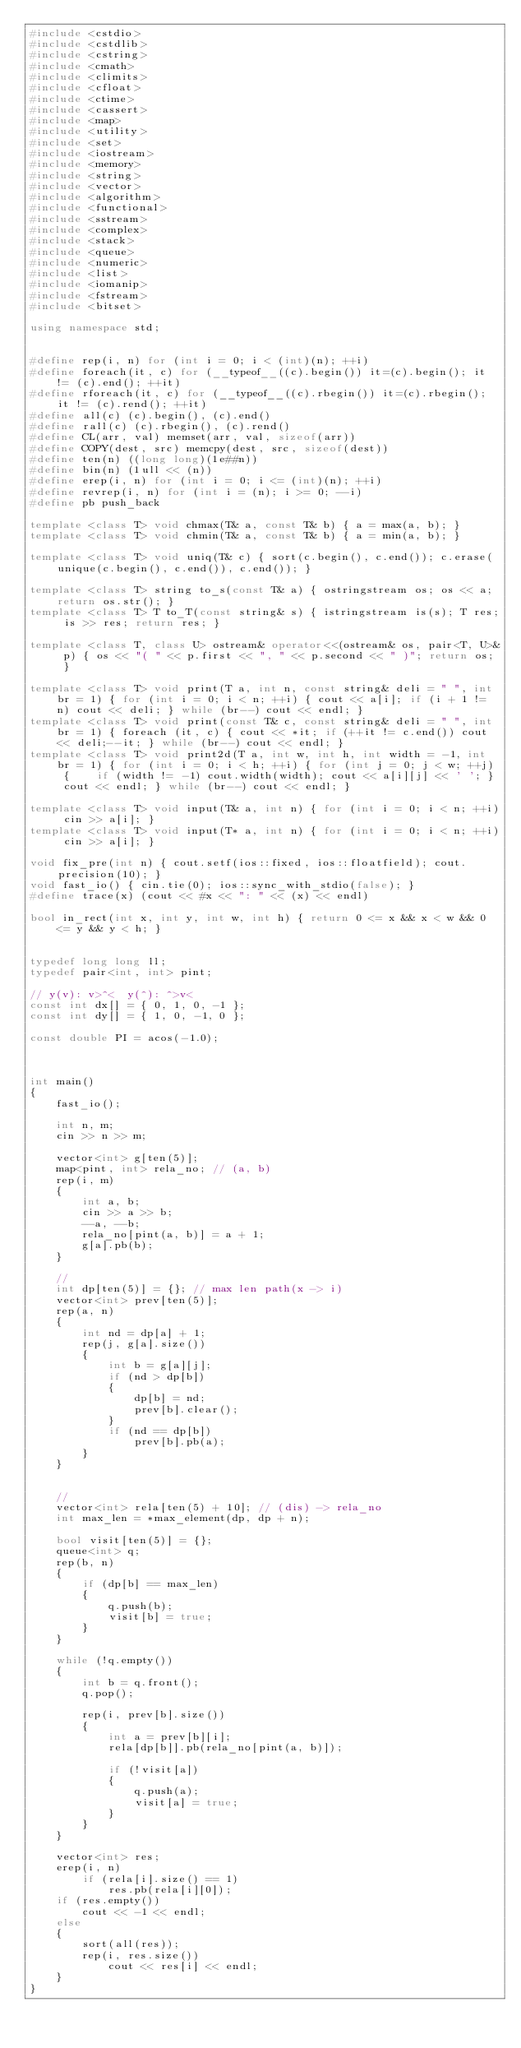Convert code to text. <code><loc_0><loc_0><loc_500><loc_500><_C++_>#include <cstdio>
#include <cstdlib>
#include <cstring>
#include <cmath>
#include <climits>
#include <cfloat>
#include <ctime>
#include <cassert>
#include <map>
#include <utility>
#include <set>
#include <iostream>
#include <memory>
#include <string>
#include <vector>
#include <algorithm>
#include <functional>
#include <sstream>
#include <complex>
#include <stack>
#include <queue>
#include <numeric>
#include <list>
#include <iomanip>
#include <fstream>
#include <bitset>
   
using namespace std;
   
 
#define rep(i, n) for (int i = 0; i < (int)(n); ++i)
#define foreach(it, c) for (__typeof__((c).begin()) it=(c).begin(); it != (c).end(); ++it)
#define rforeach(it, c) for (__typeof__((c).rbegin()) it=(c).rbegin(); it != (c).rend(); ++it)
#define all(c) (c).begin(), (c).end()
#define rall(c) (c).rbegin(), (c).rend()
#define CL(arr, val) memset(arr, val, sizeof(arr))
#define COPY(dest, src) memcpy(dest, src, sizeof(dest))
#define ten(n) ((long long)(1e##n))
#define bin(n) (1ull << (n))
#define erep(i, n) for (int i = 0; i <= (int)(n); ++i)
#define revrep(i, n) for (int i = (n); i >= 0; --i)
#define pb push_back

template <class T> void chmax(T& a, const T& b) { a = max(a, b); }
template <class T> void chmin(T& a, const T& b) { a = min(a, b); }

template <class T> void uniq(T& c) { sort(c.begin(), c.end()); c.erase(unique(c.begin(), c.end()), c.end()); }
 
template <class T> string to_s(const T& a) { ostringstream os; os << a; return os.str(); }
template <class T> T to_T(const string& s) { istringstream is(s); T res; is >> res; return res; }
  
template <class T, class U> ostream& operator<<(ostream& os, pair<T, U>& p) { os << "( " << p.first << ", " << p.second << " )"; return os; }
  
template <class T> void print(T a, int n, const string& deli = " ", int br = 1) { for (int i = 0; i < n; ++i) { cout << a[i]; if (i + 1 != n) cout << deli; } while (br--) cout << endl; }
template <class T> void print(const T& c, const string& deli = " ", int br = 1) { foreach (it, c) { cout << *it; if (++it != c.end()) cout << deli;--it; } while (br--) cout << endl; }
template <class T> void print2d(T a, int w, int h, int width = -1, int br = 1) { for (int i = 0; i < h; ++i) { for (int j = 0; j < w; ++j) {    if (width != -1) cout.width(width); cout << a[i][j] << ' '; } cout << endl; } while (br--) cout << endl; }
   
template <class T> void input(T& a, int n) { for (int i = 0; i < n; ++i) cin >> a[i]; }
template <class T> void input(T* a, int n) { for (int i = 0; i < n; ++i) cin >> a[i]; }

void fix_pre(int n) { cout.setf(ios::fixed, ios::floatfield); cout.precision(10); }
void fast_io() { cin.tie(0); ios::sync_with_stdio(false); }
#define trace(x) (cout << #x << ": " << (x) << endl)
 
bool in_rect(int x, int y, int w, int h) { return 0 <= x && x < w && 0 <= y && y < h; }


typedef long long ll;
typedef pair<int, int> pint;
 
// y(v): v>^<  y(^): ^>v<
const int dx[] = { 0, 1, 0, -1 };
const int dy[] = { 1, 0, -1, 0 };

const double PI = acos(-1.0);



int main()
{
    fast_io();

    int n, m;
    cin >> n >> m;

    vector<int> g[ten(5)];
    map<pint, int> rela_no; // (a, b)
    rep(i, m)
    {
        int a, b;
        cin >> a >> b;
        --a, --b;
        rela_no[pint(a, b)] = a + 1;
        g[a].pb(b);
    }

    // 
    int dp[ten(5)] = {}; // max len path(x -> i)
    vector<int> prev[ten(5)];
    rep(a, n)
    {
        int nd = dp[a] + 1;
        rep(j, g[a].size())
        {
            int b = g[a][j];
            if (nd > dp[b])
            {
                dp[b] = nd;
                prev[b].clear();
            }
            if (nd == dp[b])
                prev[b].pb(a);
        }
    }


    // 
    vector<int> rela[ten(5) + 10]; // (dis) -> rela_no
    int max_len = *max_element(dp, dp + n);

    bool visit[ten(5)] = {};
    queue<int> q;
    rep(b, n)
    {
        if (dp[b] == max_len)
        {
            q.push(b);
            visit[b] = true;
        }
    }

    while (!q.empty())
    {
        int b = q.front();
        q.pop();
        
        rep(i, prev[b].size())
        {
            int a = prev[b][i];
            rela[dp[b]].pb(rela_no[pint(a, b)]);

            if (!visit[a])
            {
                q.push(a);
                visit[a] = true;
            }
        }
    }

    vector<int> res;
    erep(i, n)
        if (rela[i].size() == 1)
            res.pb(rela[i][0]);
    if (res.empty())
        cout << -1 << endl;
    else
    {
        sort(all(res));
        rep(i, res.size())
            cout << res[i] << endl;
    }
}</code> 